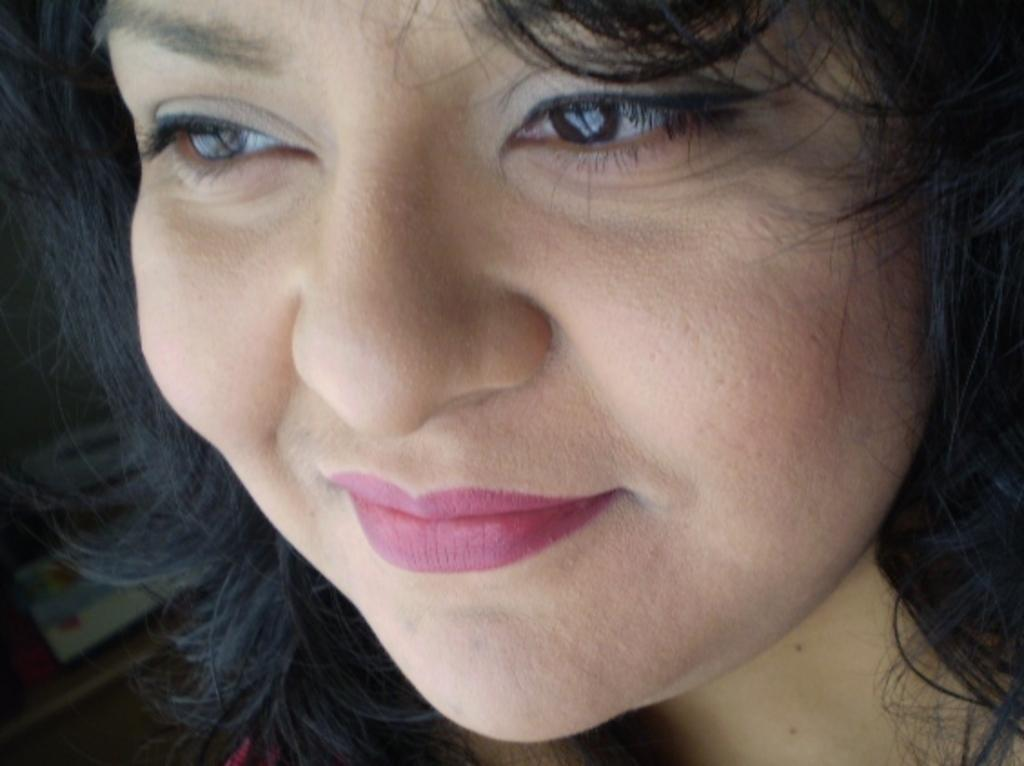Who is present in the image? There is a woman in the image. What type of oranges is the woman holding in the image? There is no reference to oranges or any fruit in the image, so it is not possible to determine what type of oranges might be held. 